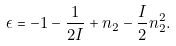Convert formula to latex. <formula><loc_0><loc_0><loc_500><loc_500>\epsilon = - 1 - \frac { 1 } { 2 I } + n _ { 2 } - \frac { I } { 2 } n _ { 2 } ^ { 2 } .</formula> 